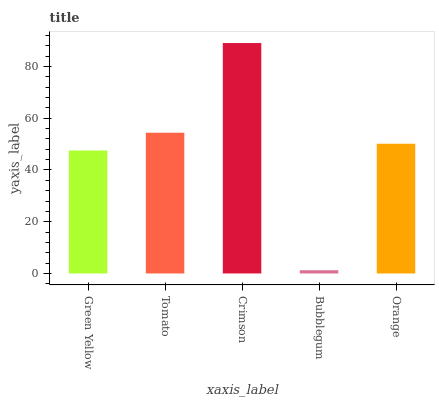Is Bubblegum the minimum?
Answer yes or no. Yes. Is Crimson the maximum?
Answer yes or no. Yes. Is Tomato the minimum?
Answer yes or no. No. Is Tomato the maximum?
Answer yes or no. No. Is Tomato greater than Green Yellow?
Answer yes or no. Yes. Is Green Yellow less than Tomato?
Answer yes or no. Yes. Is Green Yellow greater than Tomato?
Answer yes or no. No. Is Tomato less than Green Yellow?
Answer yes or no. No. Is Orange the high median?
Answer yes or no. Yes. Is Orange the low median?
Answer yes or no. Yes. Is Tomato the high median?
Answer yes or no. No. Is Bubblegum the low median?
Answer yes or no. No. 